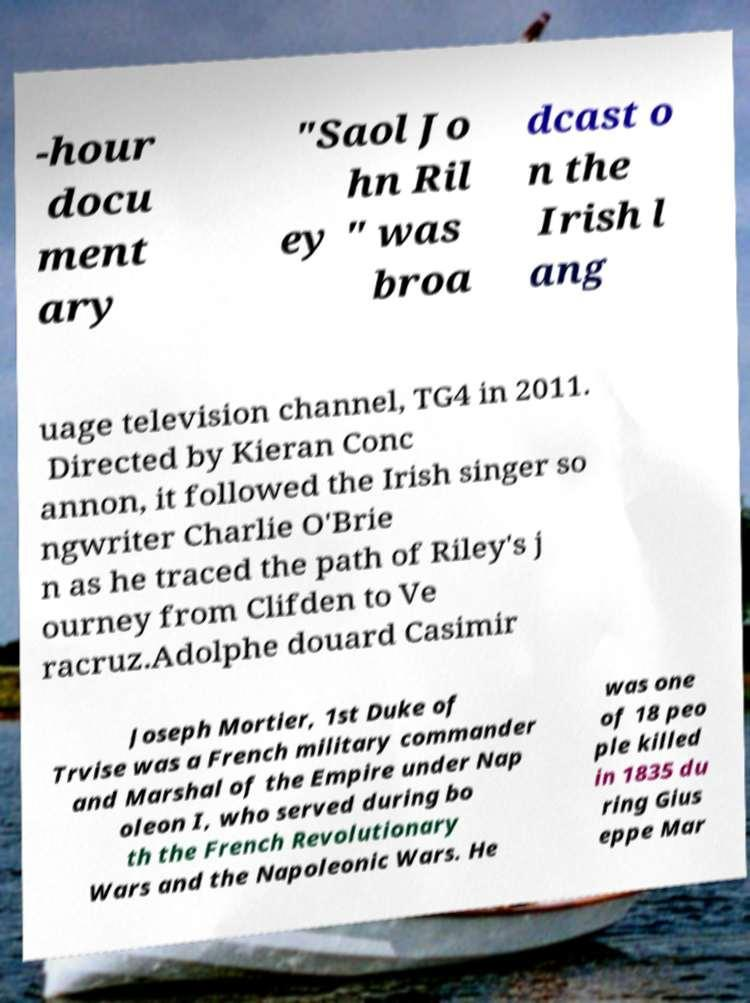Could you assist in decoding the text presented in this image and type it out clearly? -hour docu ment ary "Saol Jo hn Ril ey " was broa dcast o n the Irish l ang uage television channel, TG4 in 2011. Directed by Kieran Conc annon, it followed the Irish singer so ngwriter Charlie O'Brie n as he traced the path of Riley's j ourney from Clifden to Ve racruz.Adolphe douard Casimir Joseph Mortier, 1st Duke of Trvise was a French military commander and Marshal of the Empire under Nap oleon I, who served during bo th the French Revolutionary Wars and the Napoleonic Wars. He was one of 18 peo ple killed in 1835 du ring Gius eppe Mar 